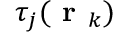Convert formula to latex. <formula><loc_0><loc_0><loc_500><loc_500>\tau _ { j } ( r _ { k } )</formula> 